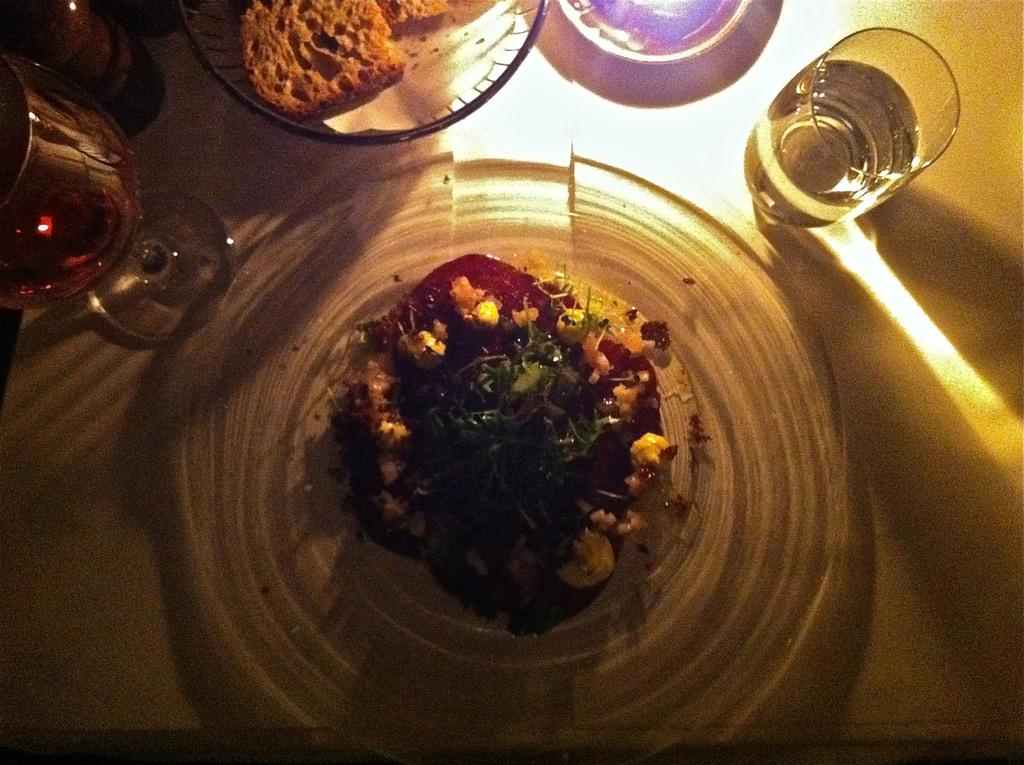What is on the plate in the image? There is a food item on a plate in the image. Where is the plate located in the image? The plate is on the right side of the image. What is in the glass that is visible in the image? There is water in the glass in the image. How many baskets are present in the image? There are no baskets present in the image. Is there a squirrel interacting with the food item on the plate? There is no squirrel present in the image. 